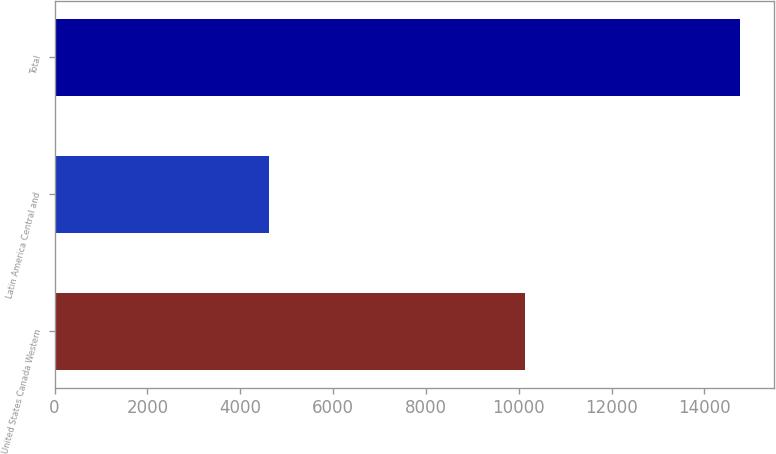Convert chart. <chart><loc_0><loc_0><loc_500><loc_500><bar_chart><fcel>United States Canada Western<fcel>Latin America Central and<fcel>Total<nl><fcel>10145<fcel>4621<fcel>14766<nl></chart> 